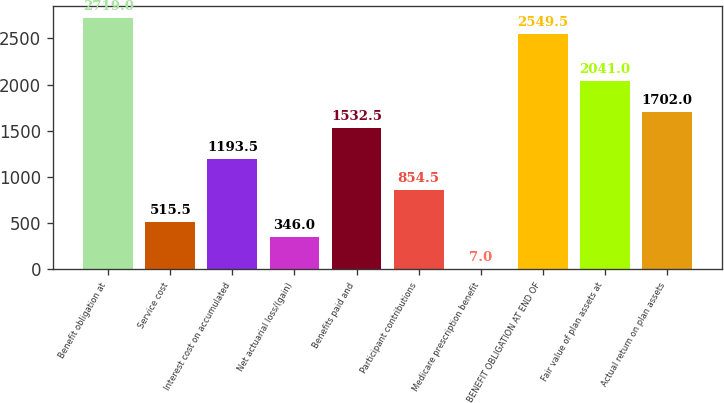Convert chart to OTSL. <chart><loc_0><loc_0><loc_500><loc_500><bar_chart><fcel>Benefit obligation at<fcel>Service cost<fcel>Interest cost on accumulated<fcel>Net actuarial loss/(gain)<fcel>Benefits paid and<fcel>Participant contributions<fcel>Medicare prescription benefit<fcel>BENEFIT OBLIGATION AT END OF<fcel>Fair value of plan assets at<fcel>Actual return on plan assets<nl><fcel>2719<fcel>515.5<fcel>1193.5<fcel>346<fcel>1532.5<fcel>854.5<fcel>7<fcel>2549.5<fcel>2041<fcel>1702<nl></chart> 